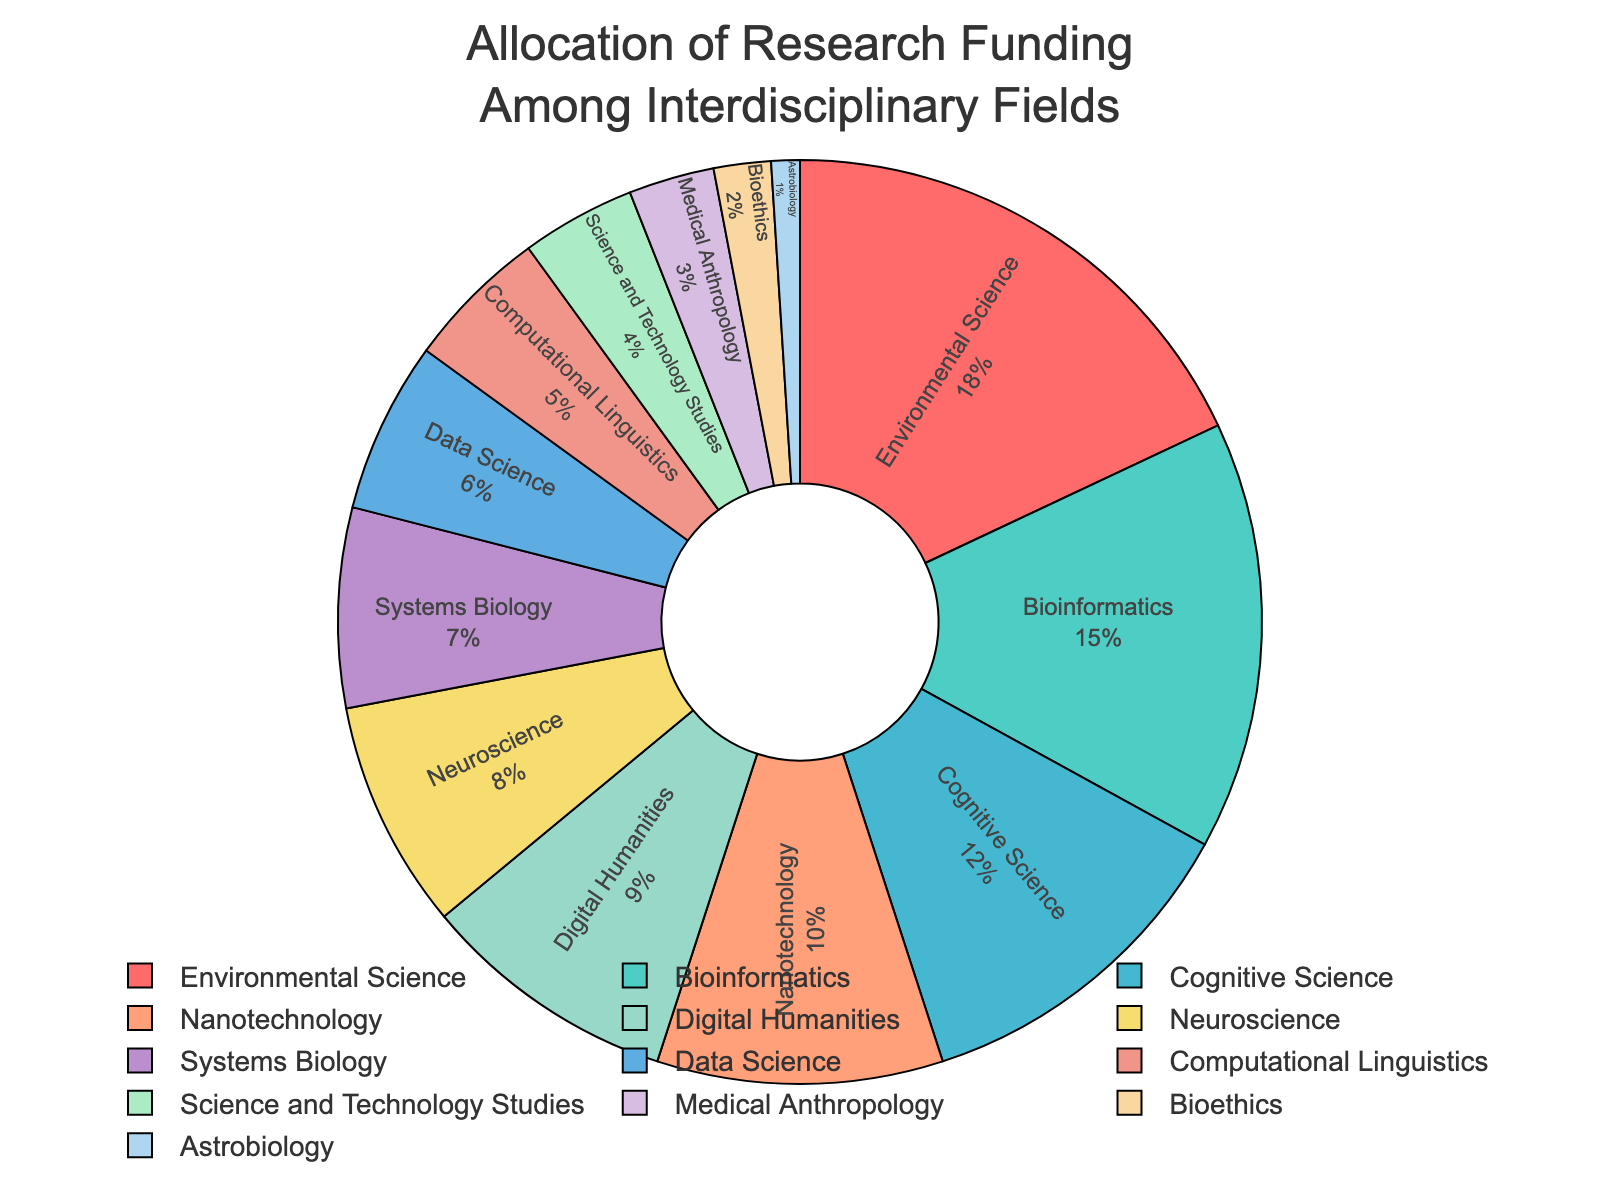What percentage of the total funding is allocated to fields related to biology (Bioinformatics, Neuroscience, Systems Biology, Medical Anthropology)? First, find the percentages for Bioinformatics (15%), Neuroscience (8%), Systems Biology (7%), and Medical Anthropology (3%). Then, sum these percentages: 15 + 8 + 7 + 3 = 33%.
Answer: 33% Which field receives more funding, Cognitive Science or Nanotechnology? Cognitive Science receives 12% of the funding, while Nanotechnology receives 10%. 12% is greater than 10%.
Answer: Cognitive Science What is the combined percentage of funding for fields that are allocated less than 5% each? Identify fields with less than 5%: Science and Technology Studies (4%), Medical Anthropology (3%), Bioethics (2%), and Astrobiology (1%). Sum their percentages: 4 + 3 + 2 + 1 = 10%.
Answer: 10% Which field has the smallest allocation of research funding, and what is its percentage? Look for the field with the smallest percentage allocation. Astrobiology has the smallest allocation with 1%.
Answer: Astrobiology, 1% How much more funding does Environmental Science receive compared to Digital Humanities? Environmental Science is allocated 18% of the funding, while Digital Humanities gets 9%. The difference is 18 - 9 = 9%.
Answer: 9% What is the average funding percentage for fields that receive more than 10% of the allocation? Identify fields with more than 10%: Environmental Science (18%), Bioinformatics (15%), and Cognitive Science (12%). Calculate the average: (18 + 15 + 12) / 3 = 45 / 3 = 15%.
Answer: 15% How does the funding allocation for Data Science compare to Systems Biology? Data Science is allocated 6% of the funding, while Systems Biology gets 7%. Hence, Systems Biology receives 1% more funding than Data Science.
Answer: Systems Biology receives 1% more Which field uses a blue-ish color in the pie chart, and what is its funding percentage? From the color description, "#45B7D1" is a blue-ish color. The corresponding field is Cognitive Science with a funding percentage of 12%.
Answer: Cognitive Science, 12% Arrange the fields in descending order of funding allocation. The fields from highest to lowest funding are: Environmental Science (18%), Bioinformatics (15%), Cognitive Science (12%), Nanotechnology (10%), Digital Humanities (9%), Neuroscience (8%), Systems Biology (7%), Data Science (6%), Computational Linguistics (5%), Science and Technology Studies (4%), Medical Anthropology (3%), Bioethics (2%), Astrobiology (1%).
Answer: Environmental Science, Bioinformatics, Cognitive Science, Nanotechnology, Digital Humanities, Neuroscience, Systems Biology, Data Science, Computational Linguistics, Science and Technology Studies, Medical Anthropology, Bioethics, Astrobiology 